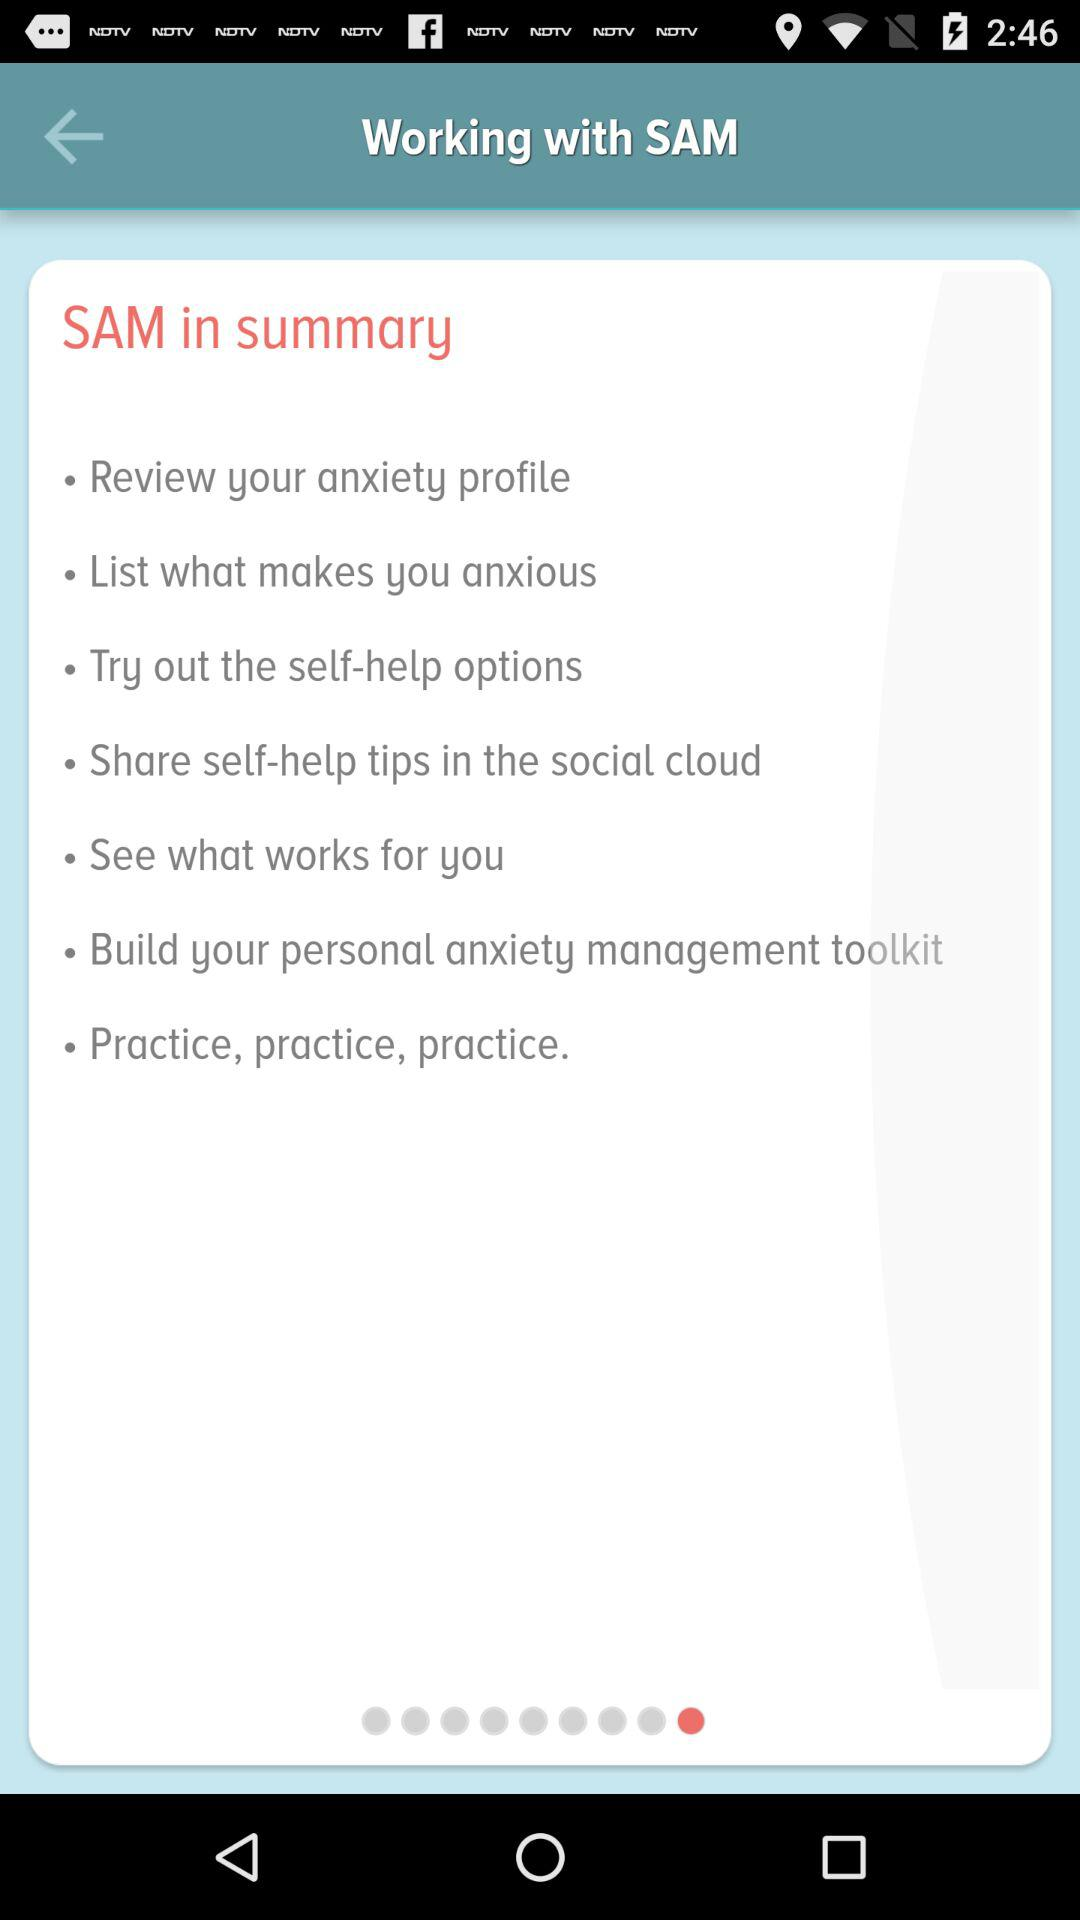What is the summary of "SAM"? The summary of "SAM" is "Review your anxiety profile", "List what makes you anxious", "Try out the self-help options", "Share self-help tips in the social cloud", "See what works for you", "Build your personal anxiety management toolkit" and "Practice, practice, practice". 